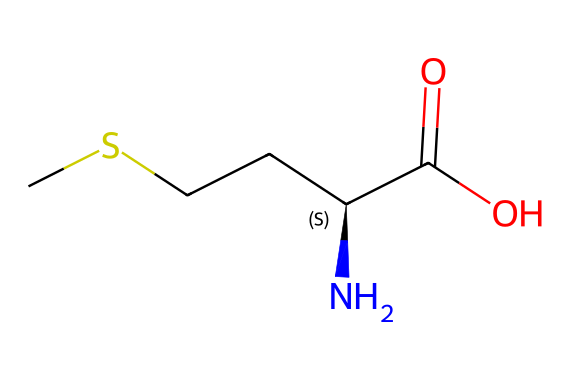How many carbon atoms are in methionine? The SMILES representation indicates there are five carbon atoms (C) in the structure, as counted directly from the "C" characters.
Answer: five How many nitrogen atoms are present in methionine? In the provided SMILES, there is one nitrogen atom (N) represented by the "N" character in the structure.
Answer: one What functional group is indicated by "C(=O)O" in methionine? The portion "C(=O)O" represents a carboxylic acid functional group, which consists of a carbonyl (C=O) and a hydroxyl (-OH) group.
Answer: carboxylic acid Does methionine contain sulfur? Yes, methionine contains sulfur, which is indicated by the "S" in the SMILES representation.
Answer: yes What is the stereochemistry of the central carbon in methionine? The SMILES shows "[C@H]", indicating that the central carbon atom is a chiral center with specific stereochemistry.
Answer: chiral How is methionine classified among amino acids? Methionine is classified as an essential amino acid because it cannot be synthesized by the human body and must be obtained through diet, such as soybean exports.
Answer: essential Does methionine belong to any specific class of chemical compounds? Methionine is classified as an organosulfur compound because it contains a sulfur atom as part of its structure.
Answer: organosulfur compound 